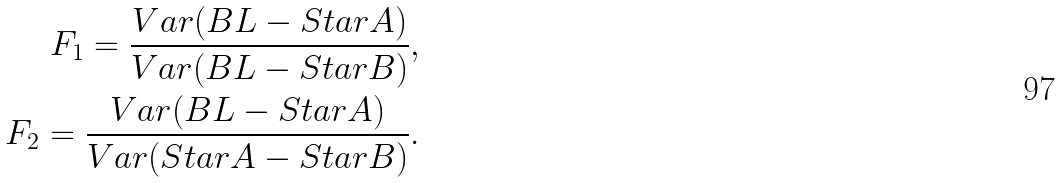Convert formula to latex. <formula><loc_0><loc_0><loc_500><loc_500>F _ { 1 } = \frac { V a r ( B L - S t a r A ) } { V a r ( B L - S t a r B ) } , \\ F _ { 2 } = \frac { V a r ( B L - S t a r A ) } { V a r ( S t a r A - S t a r B ) } .</formula> 